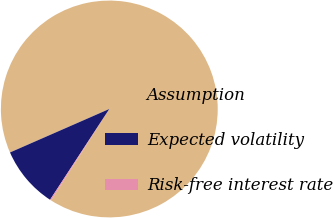Convert chart to OTSL. <chart><loc_0><loc_0><loc_500><loc_500><pie_chart><fcel>Assumption<fcel>Expected volatility<fcel>Risk-free interest rate<nl><fcel>90.59%<fcel>9.23%<fcel>0.18%<nl></chart> 